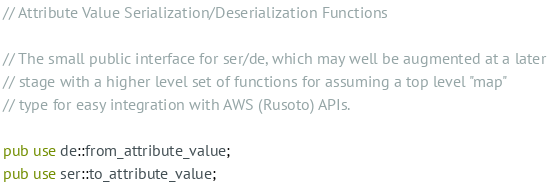Convert code to text. <code><loc_0><loc_0><loc_500><loc_500><_Rust_>// Attribute Value Serialization/Deserialization Functions

// The small public interface for ser/de, which may well be augmented at a later
// stage with a higher level set of functions for assuming a top level "map"
// type for easy integration with AWS (Rusoto) APIs.

pub use de::from_attribute_value;
pub use ser::to_attribute_value;
</code> 